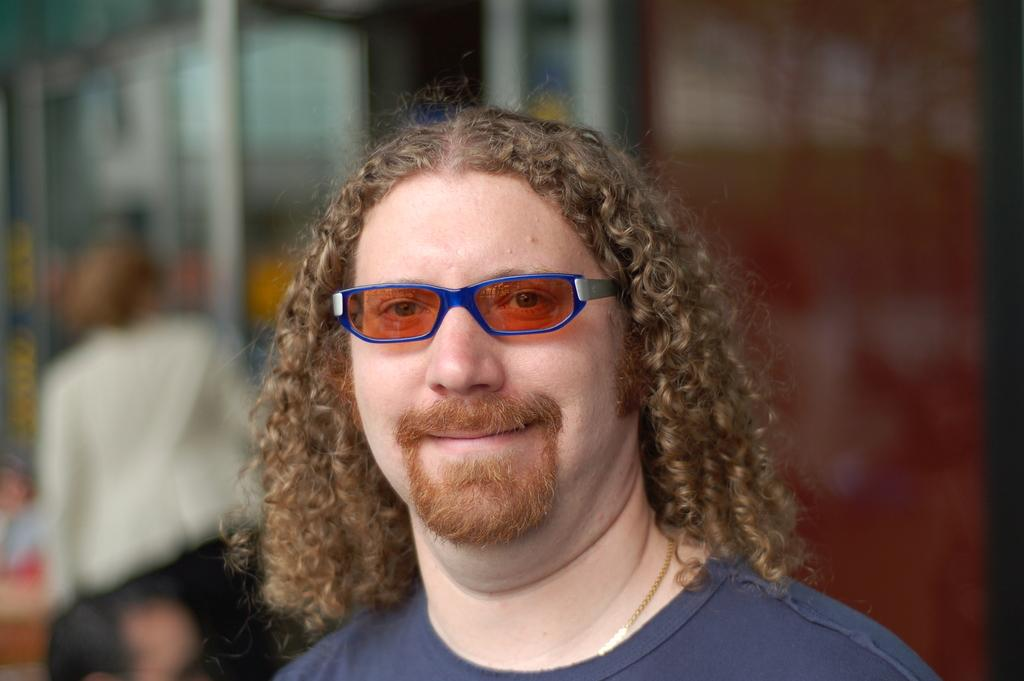What is the main subject of the image? There is a person in the image. What is the person wearing? The person is wearing a blue shirt. Can you describe the background of the image? The background of the image is blurred. What type of quartz can be seen in the person's pocket in the image? There is no quartz visible in the image, and the person's pocket is not mentioned in the provided facts. 